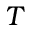Convert formula to latex. <formula><loc_0><loc_0><loc_500><loc_500>T</formula> 